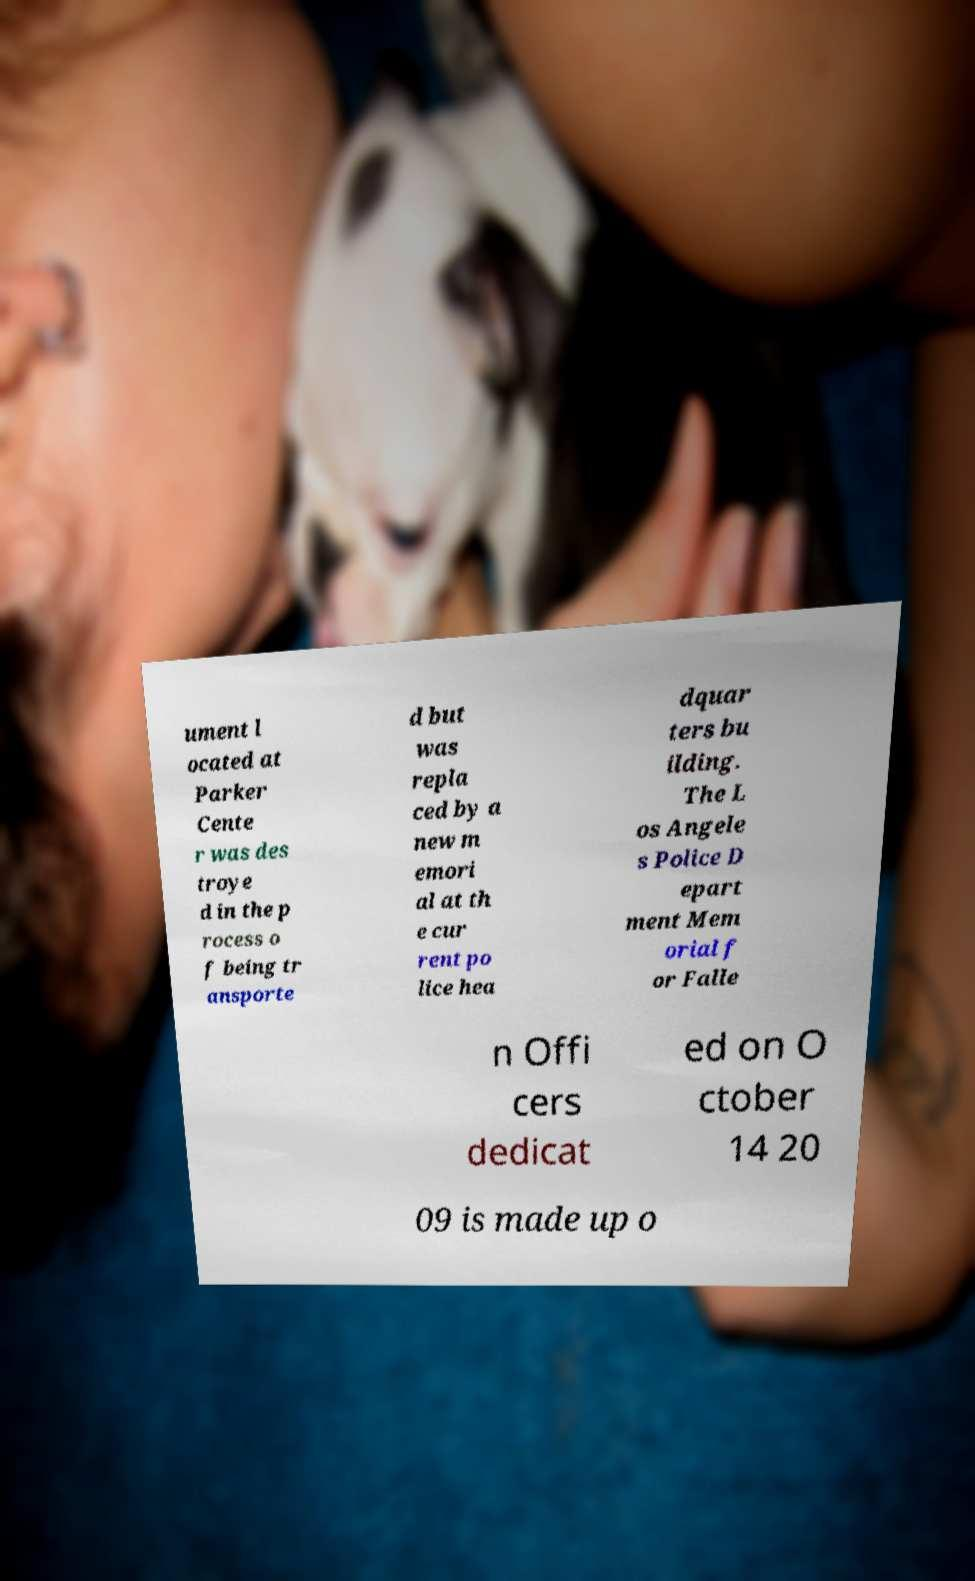I need the written content from this picture converted into text. Can you do that? ument l ocated at Parker Cente r was des troye d in the p rocess o f being tr ansporte d but was repla ced by a new m emori al at th e cur rent po lice hea dquar ters bu ilding. The L os Angele s Police D epart ment Mem orial f or Falle n Offi cers dedicat ed on O ctober 14 20 09 is made up o 